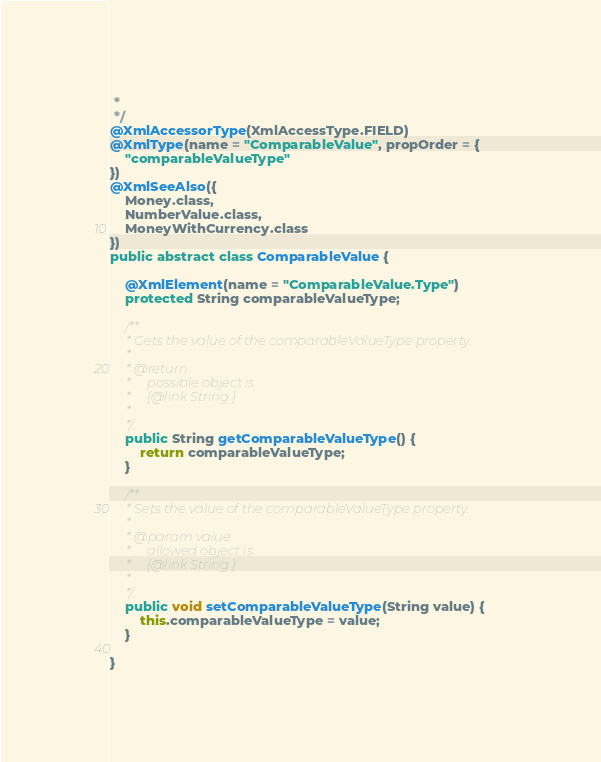Convert code to text. <code><loc_0><loc_0><loc_500><loc_500><_Java_> * 
 */
@XmlAccessorType(XmlAccessType.FIELD)
@XmlType(name = "ComparableValue", propOrder = {
    "comparableValueType"
})
@XmlSeeAlso({
    Money.class,
    NumberValue.class,
    MoneyWithCurrency.class
})
public abstract class ComparableValue {

    @XmlElement(name = "ComparableValue.Type")
    protected String comparableValueType;

    /**
     * Gets the value of the comparableValueType property.
     * 
     * @return
     *     possible object is
     *     {@link String }
     *     
     */
    public String getComparableValueType() {
        return comparableValueType;
    }

    /**
     * Sets the value of the comparableValueType property.
     * 
     * @param value
     *     allowed object is
     *     {@link String }
     *     
     */
    public void setComparableValueType(String value) {
        this.comparableValueType = value;
    }

}
</code> 